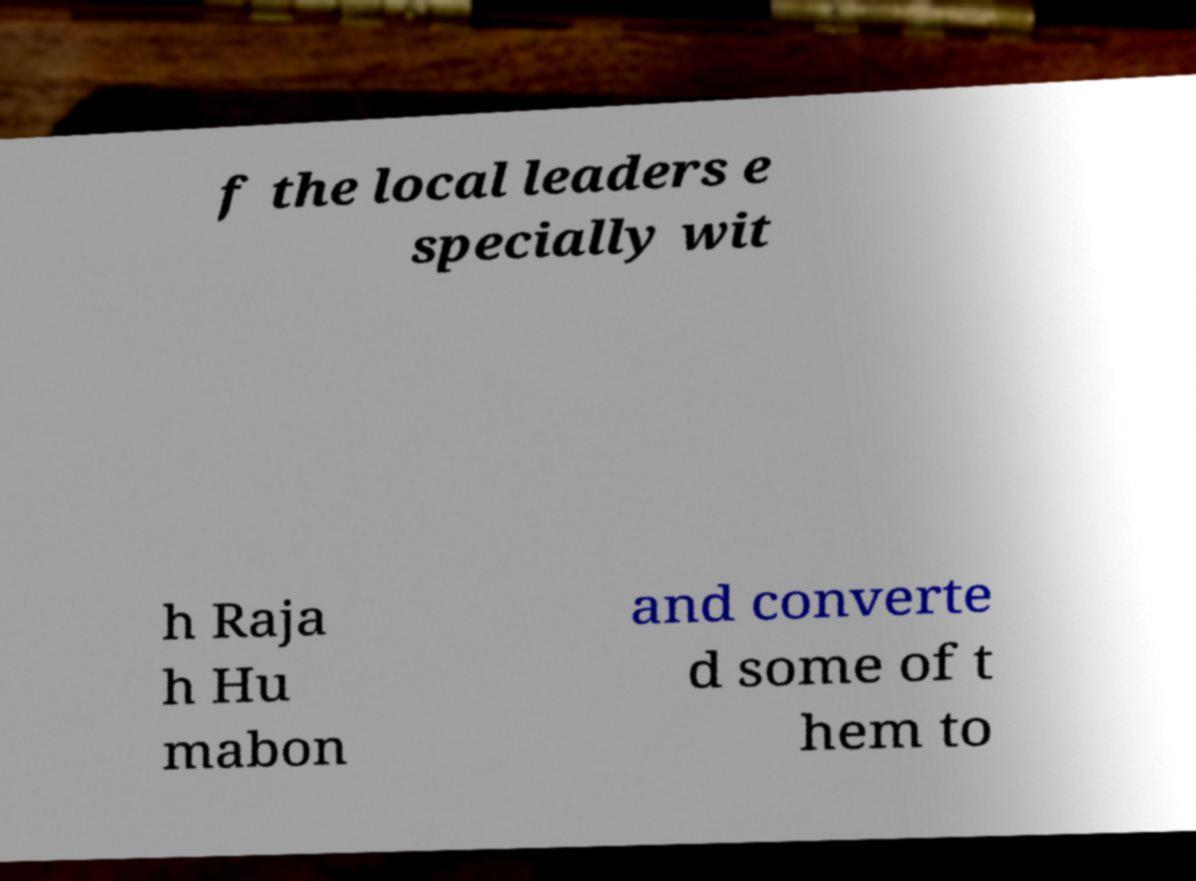What messages or text are displayed in this image? I need them in a readable, typed format. f the local leaders e specially wit h Raja h Hu mabon and converte d some of t hem to 